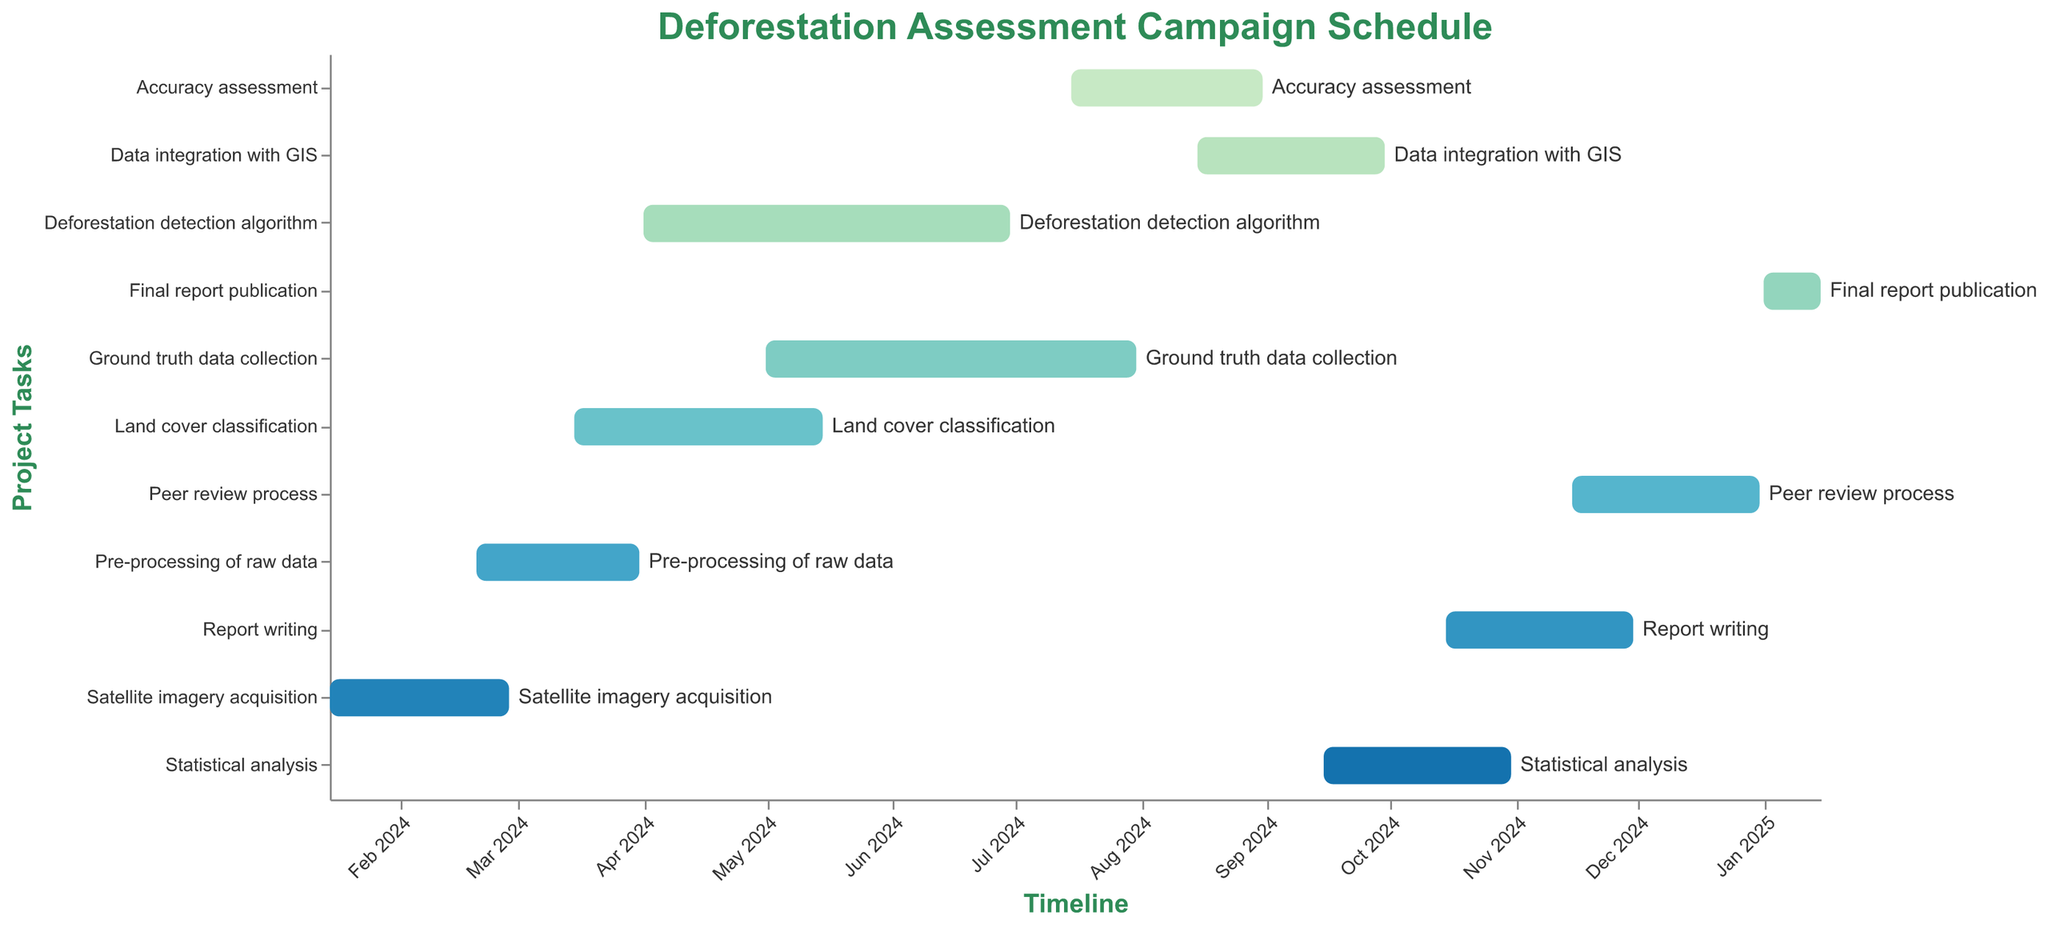How long does the "Ground truth data collection" task take? Look at the "Ground truth data collection" task bar on the Gantt chart. Identify the start and end dates from the timeline axis. Subtract the start date (2024-05-01) from the end date (2024-07-31) to find the duration.
Answer: About 3 months When does the "Accuracy assessment" begin and end? Refer to the "Accuracy assessment" task bar on the Gantt chart. Note the start date (2024-07-15) and the end date (2024-08-31) from the timeline axis.
Answer: Starts: 2024-07-15, Ends: 2024-08-31 Which task has the longest duration? Compare the lengths of all the task bars on the Gantt chart. The task with the longest bar represents the task with the longest duration.
Answer: Deforestation detection algorithm Identify two tasks that overlap in time. Observe the Gantt chart to find tasks with bars that intersect along the timeline. For example, "Pre-processing of raw data" and "Satellite imagery acquisition" overlap as their timelines intersect between 2024-02-20 and 2024-02-28.
Answer: "Pre-processing of raw data" and "Satellite imagery acquisition" What is the time gap between the end of "Statistical analysis" and the start of "Report writing"? Look at the end date of "Statistical analysis" (2024-10-31) and the start date of "Report writing" (2024-10-15). Calculate the gap by subtracting the start date from the end date. There is no time gap as "Report writing" starts before "Statistical analysis" ends.
Answer: No time gap How many tasks start in January 2024? Count the number of task bars that start within the range of January 2024 on the timeline axis.
Answer: One Which task finishes last in 2024? Look at the end dates of the tasks in 2024. Identify the task with the latest end date in the year 2024.
Answer: Peer review process What is the duration difference between "Data integration with GIS" and "Statistical analysis"? Find the duration of both tasks by subtracting their start dates from their end dates. Compare these durations. "Data integration with GIS" runs from 2024-08-15 to 2024-09-30 (1.5 months), while "Statistical analysis" runs from 2024-09-15 to 2024-10-31 (1.5 months).
Answer: No difference Does any task span across two years? Scan the Gantt chart to check if any task bars extend from one year into the next. "Final report publication" starts in 2025.
Answer: Yes, "Final report publication" Which task starts directly after the "Deforestation detection algorithm"? Look at the end date of "Deforestation detection algorithm" (2024-06-30) and identify the task that starts immediately after on the timeline.
Answer: Ground truth data collection 